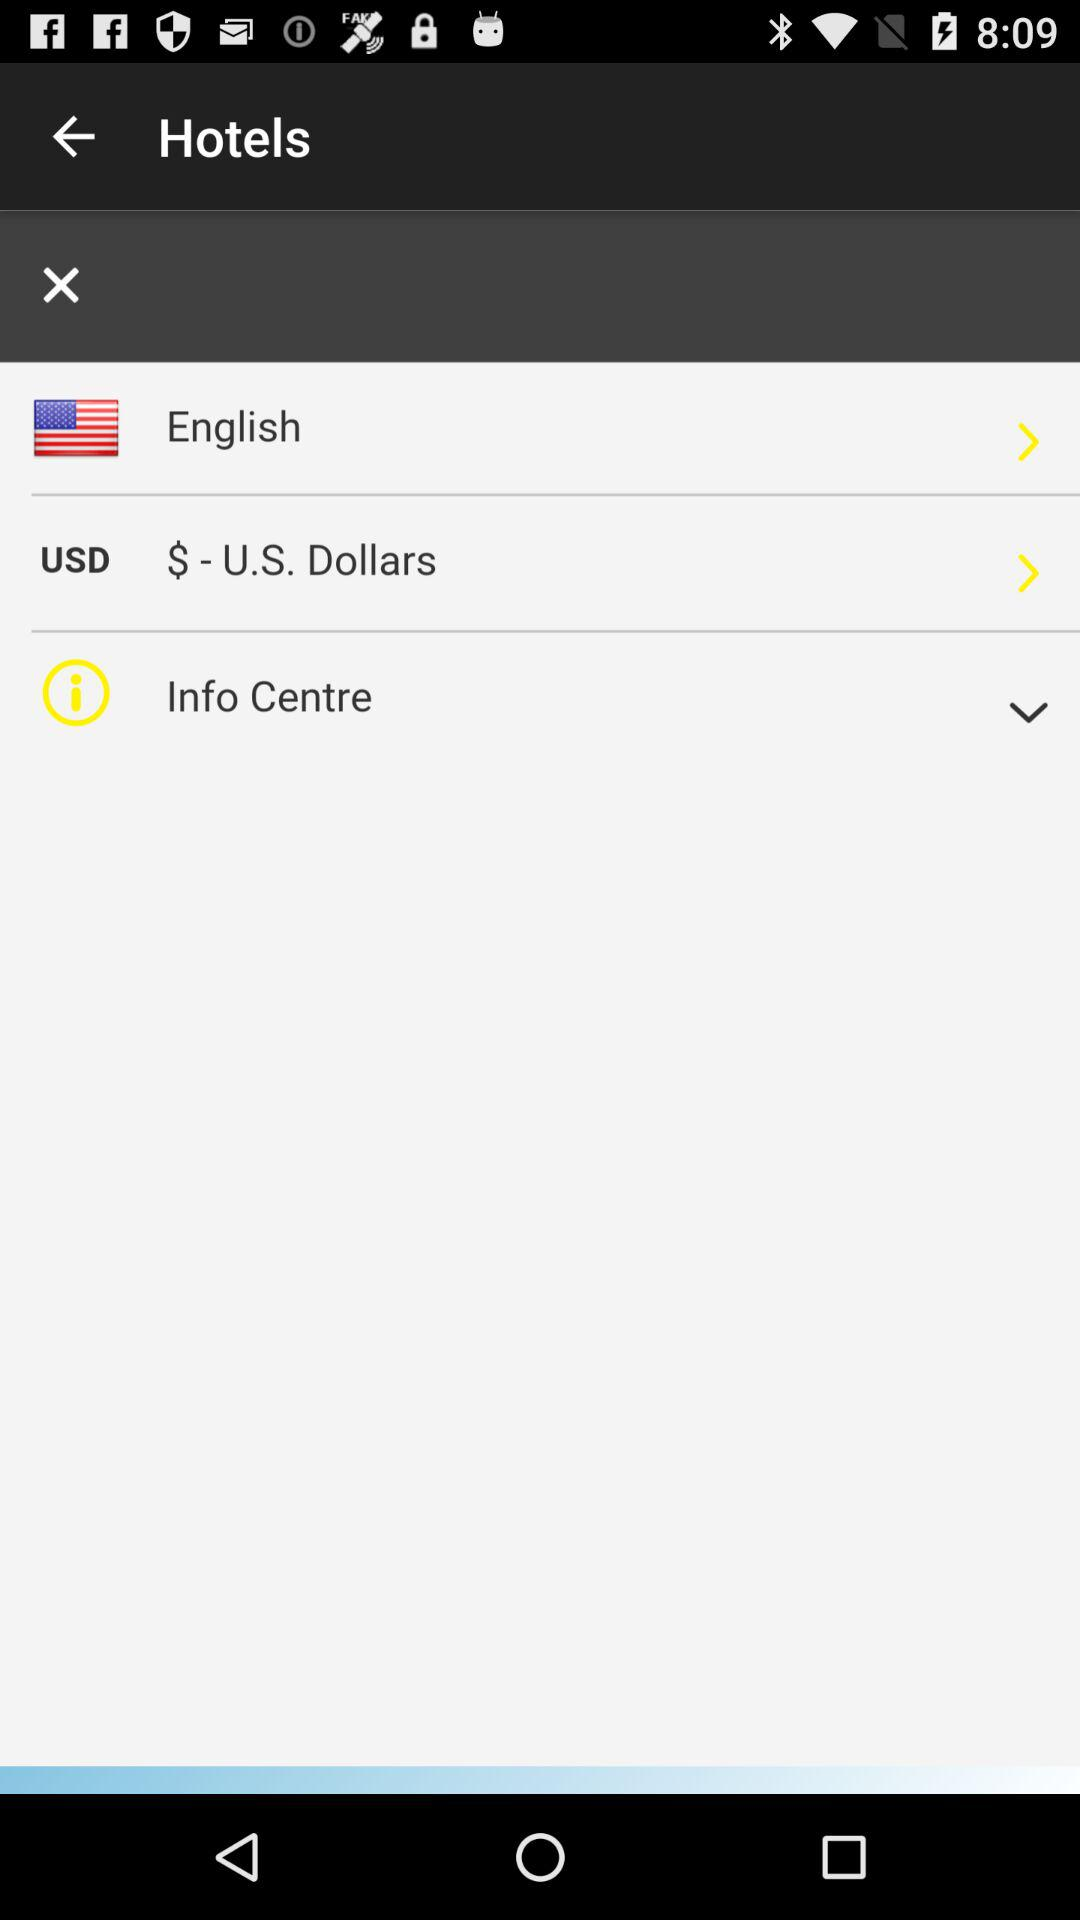What functionalities might the icons on the top right of the interface represent? The icons at the top right of the interface may include functionalities such as notifications, represented by a bell icon, and a menu or settings option, indicated by three vertical dots. These icons typically allow users to view alerts and customize their app settings or preferences. 